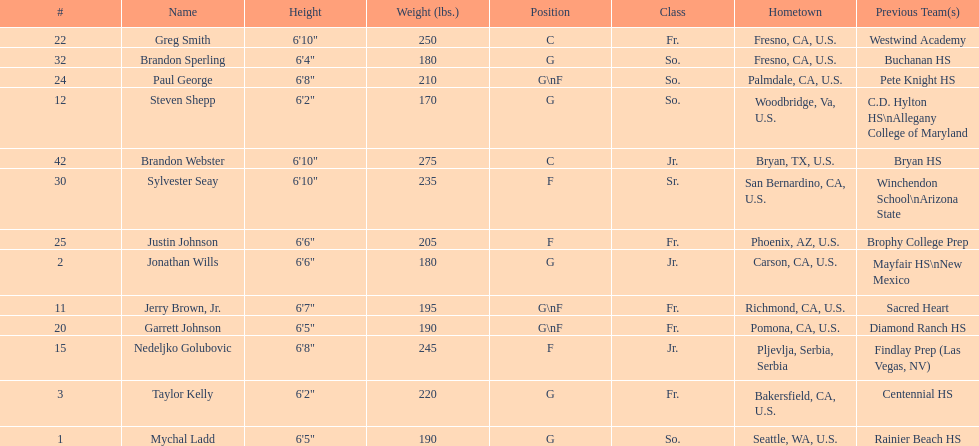What is the count of players weighing more than 200 pounds? 7. 